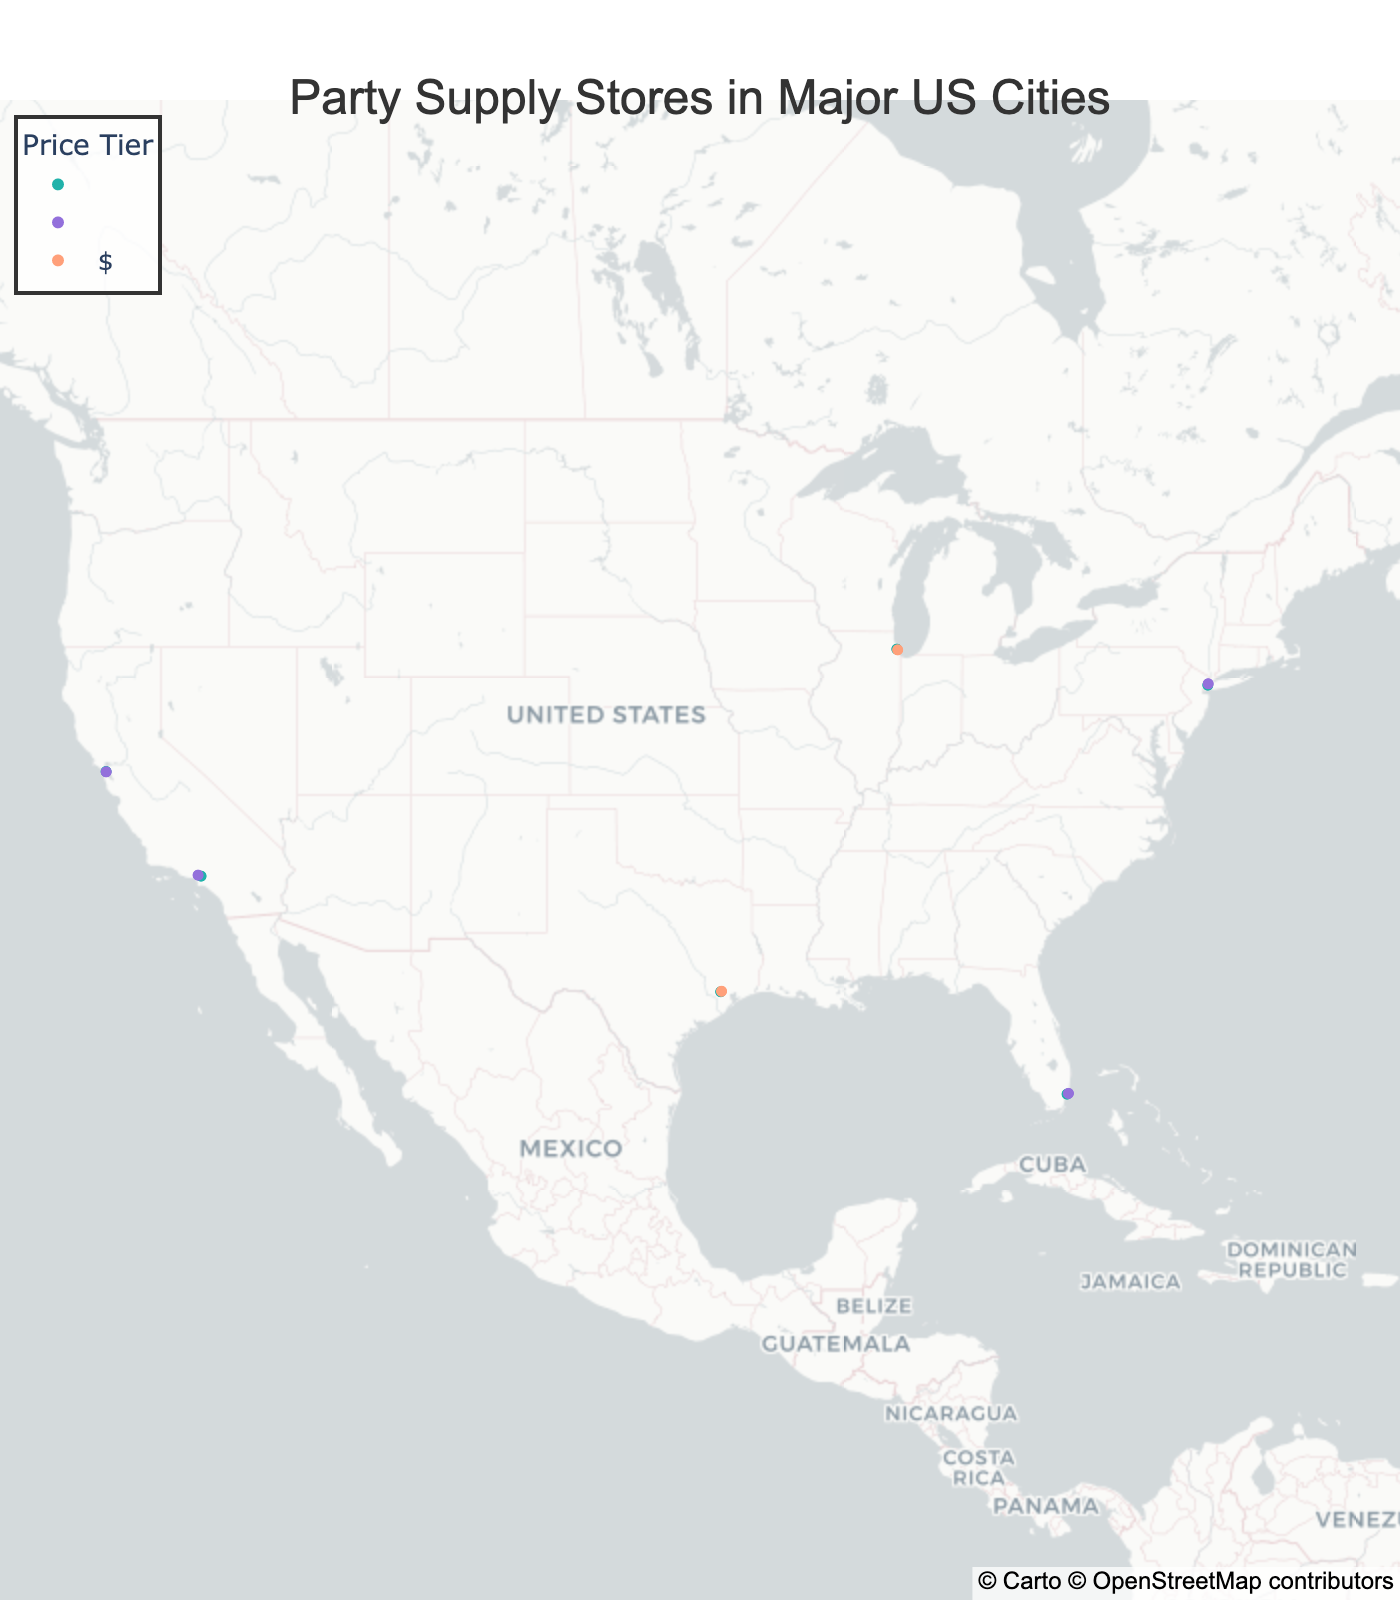What city has the highest number of party supply stores? By observing the geographic plot, you can visually count the number of markers for each city. New York has 2 markers, Los Angeles has 2 markers, Chicago has 2 markers, Houston has 2 markers, Miami has 2 markers, and San Francisco has 2 markers. Thus, multiple cities have the highest number of stores, which is 2.
Answer: New York, Los Angeles, Chicago, Houston, Miami, San Francisco Which city has the store with the specialty "High-End Costumes"? By looking at the hover information on the plot, you can identify each store's specialty. The store named "The Costumer" specializes in "High-End Costumes" and is located in San Francisco.
Answer: San Francisco How many stores have the $$ price tier? Check the color-coded markers on the map for $$ price tier and count them. There are 1 store in New York, 1 in Los Angeles, 1 in Chicago, 1 in Houston, 1 in Miami, and 1 in San Francisco, making a total of 6 stores.
Answer: 6 Which store has the longest specialty description and where is it located? Hover over each marker and read the specialty descriptions. "Balloons & Decorations" by "Balloon Saloon" in New York has the longest description.
Answer: Balloon Saloon, New York Are there more stores with general supplies specialty or those specializing in upscale decorations? By hovering over the map, you can determine the specialties. "General Supplies" appears once in New York, while "Upscale Decorations" appears once in Miami. Both categories have only 1 store.
Answer: Equal Comparing Houston and Miami, which city has more stores in the $ price tier? By checking the markers for $ price tier, you will find that Houston has 1 store ("Party Boy"), whereas Miami has none in the $ price tier.
Answer: Houston What is the most common specialty among the listed stores? By reviewing all the hover data, the specialties include General Supplies, Balloons & Decorations, Kids Party Supplies, Novelty Items, Bulk Party Supplies, Stationery & Invitations, Costumes & Accessories, Custom Decorations, Beach Party Essentials, Upscale Decorations, Eclectic Party Supplies, and High-End Costumes. No specialty repeats, so there is no most common specialty.
Answer: None Which city has the most expensive store? Identify the stores with the $$$ price tier on the map. Each city has at most one $$$ store, implying there's no single city with the most expensive stores exceeding others.
Answer: None Between New York and Los Angeles, which city offers a store specializing in "Novelty Items"? Check the hover data for specialties of stores in New York and Los Angeles. "Aahs! The Ultimate Gift Store" in Los Angeles specializes in "Novelty Items".
Answer: Los Angeles What is the average number of stores per city? Count the total number of stores and divide by the total number of cities. There are 12 stores across 6 cities, so the average is 12/6.
Answer: 2 